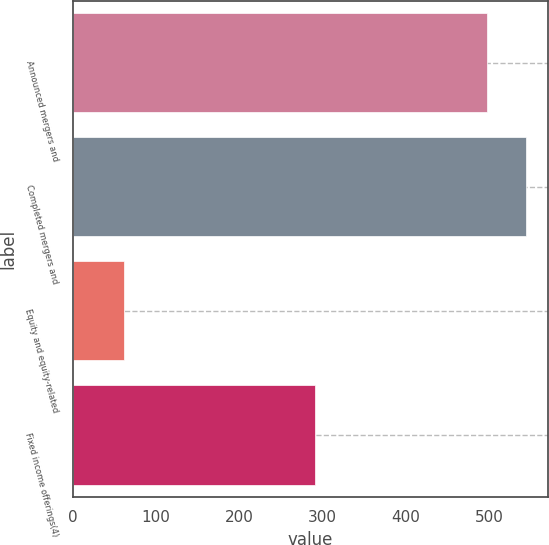Convert chart to OTSL. <chart><loc_0><loc_0><loc_500><loc_500><bar_chart><fcel>Announced mergers and<fcel>Completed mergers and<fcel>Equity and equity-related<fcel>Fixed income offerings(4)<nl><fcel>497<fcel>543.5<fcel>61<fcel>291<nl></chart> 